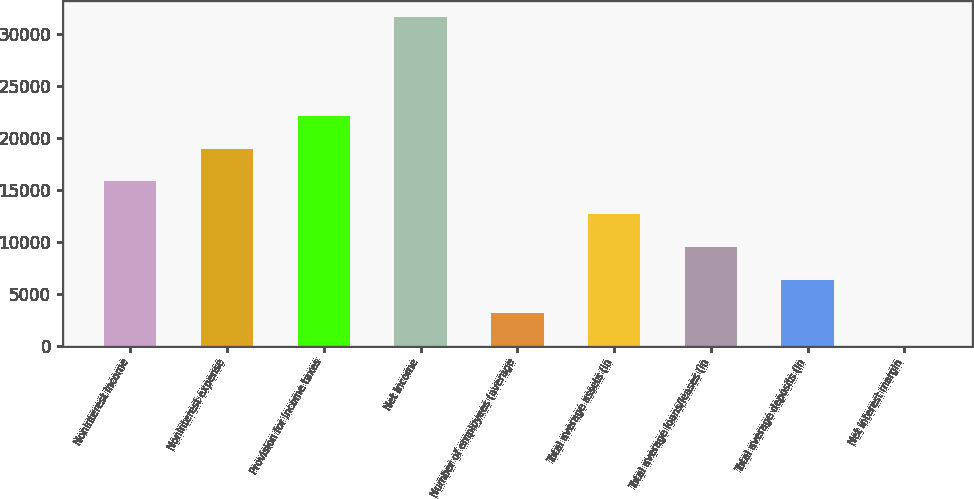Convert chart to OTSL. <chart><loc_0><loc_0><loc_500><loc_500><bar_chart><fcel>Noninterest income<fcel>Noninterest expense<fcel>Provision for income taxes<fcel>Net income<fcel>Number of employees (average<fcel>Total average assets (in<fcel>Total average loans/leases (in<fcel>Total average deposits (in<fcel>Net interest margin<nl><fcel>15799.6<fcel>18959.5<fcel>22119.4<fcel>31599<fcel>3160.14<fcel>12639.8<fcel>9479.88<fcel>6320.01<fcel>0.27<nl></chart> 